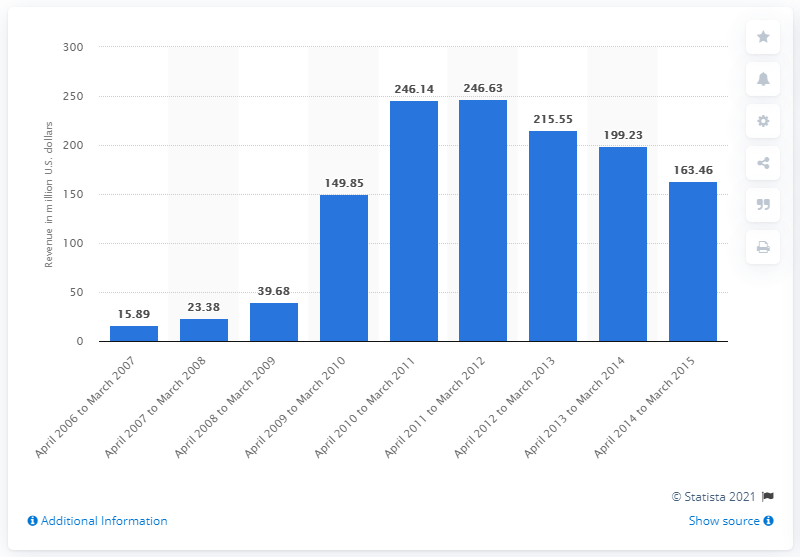Mention a couple of crucial points in this snapshot. RealD's annual revenue for the fiscal year ending March 31, 2015, was 163.46 million. 